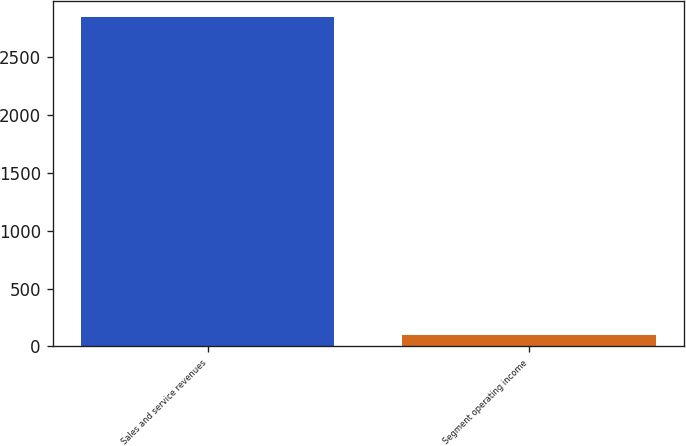Convert chart. <chart><loc_0><loc_0><loc_500><loc_500><bar_chart><fcel>Sales and service revenues<fcel>Segment operating income<nl><fcel>2840<fcel>97<nl></chart> 